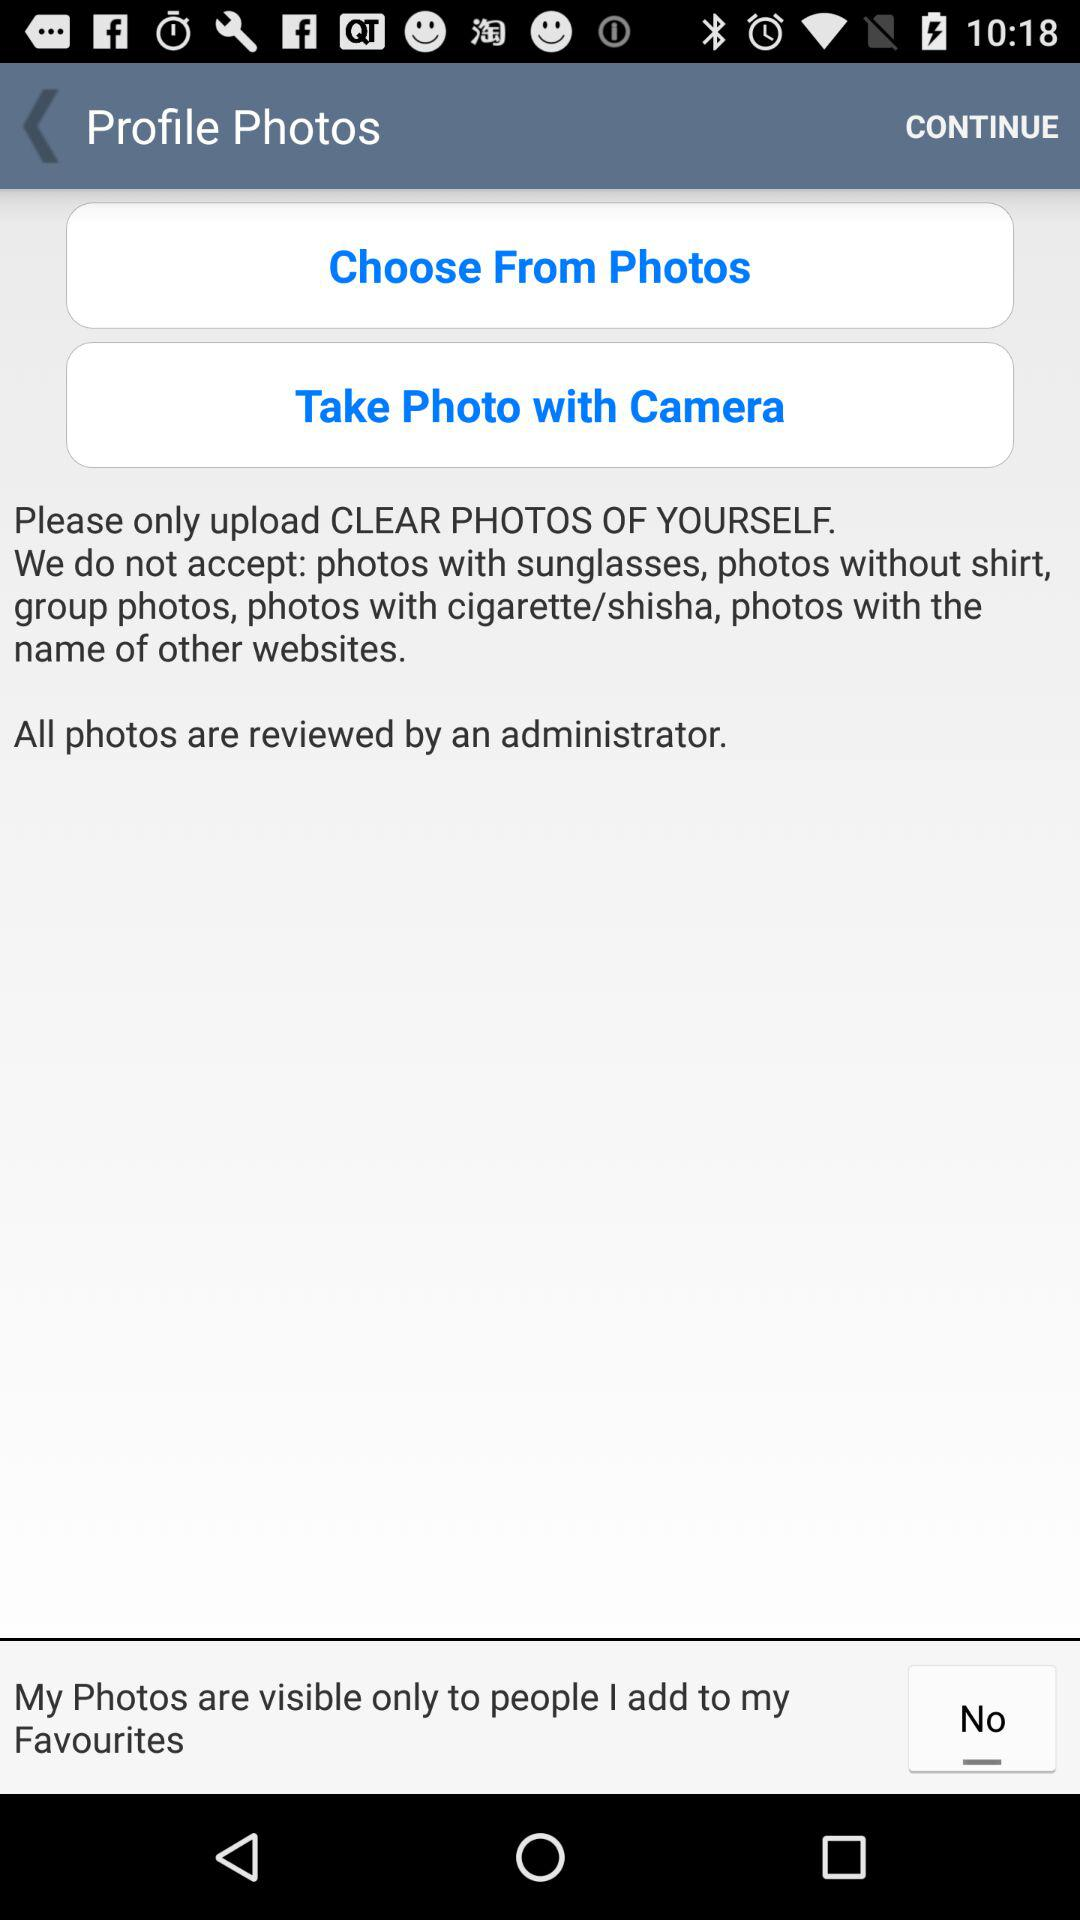What are the given options for choosing the profile photos? The given options for choosing the profile photos are : "Choose From Photos" and "Take Photo with Camera". 